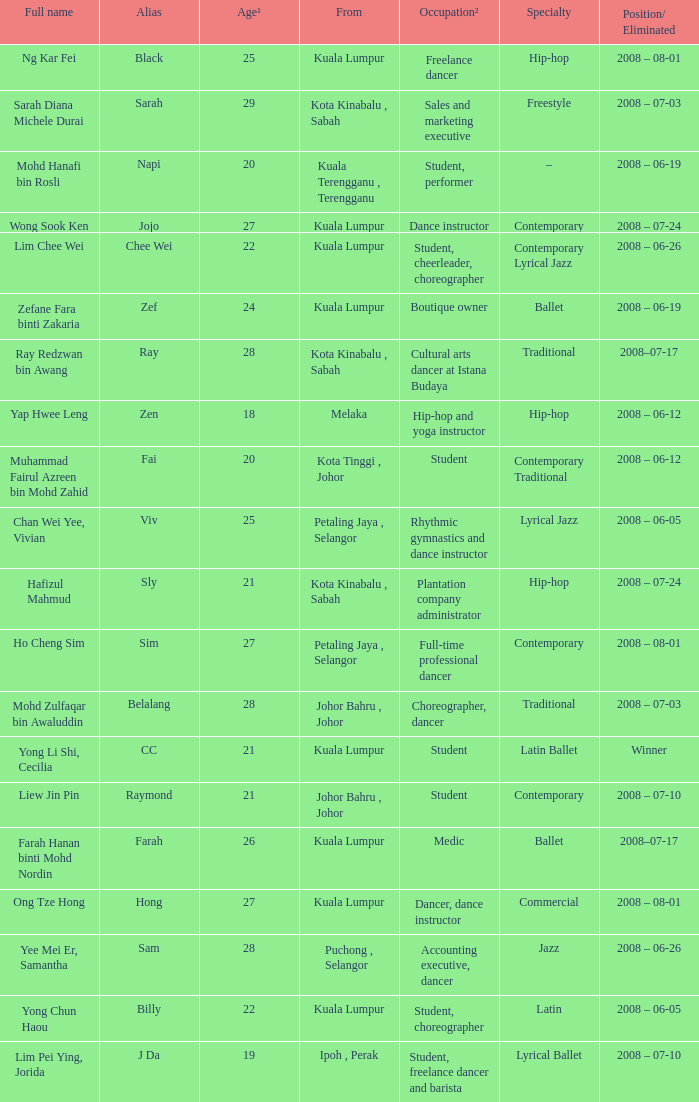What is Occupation², when Age¹ is greater than 24, when Alias is "Black"? Freelance dancer. 